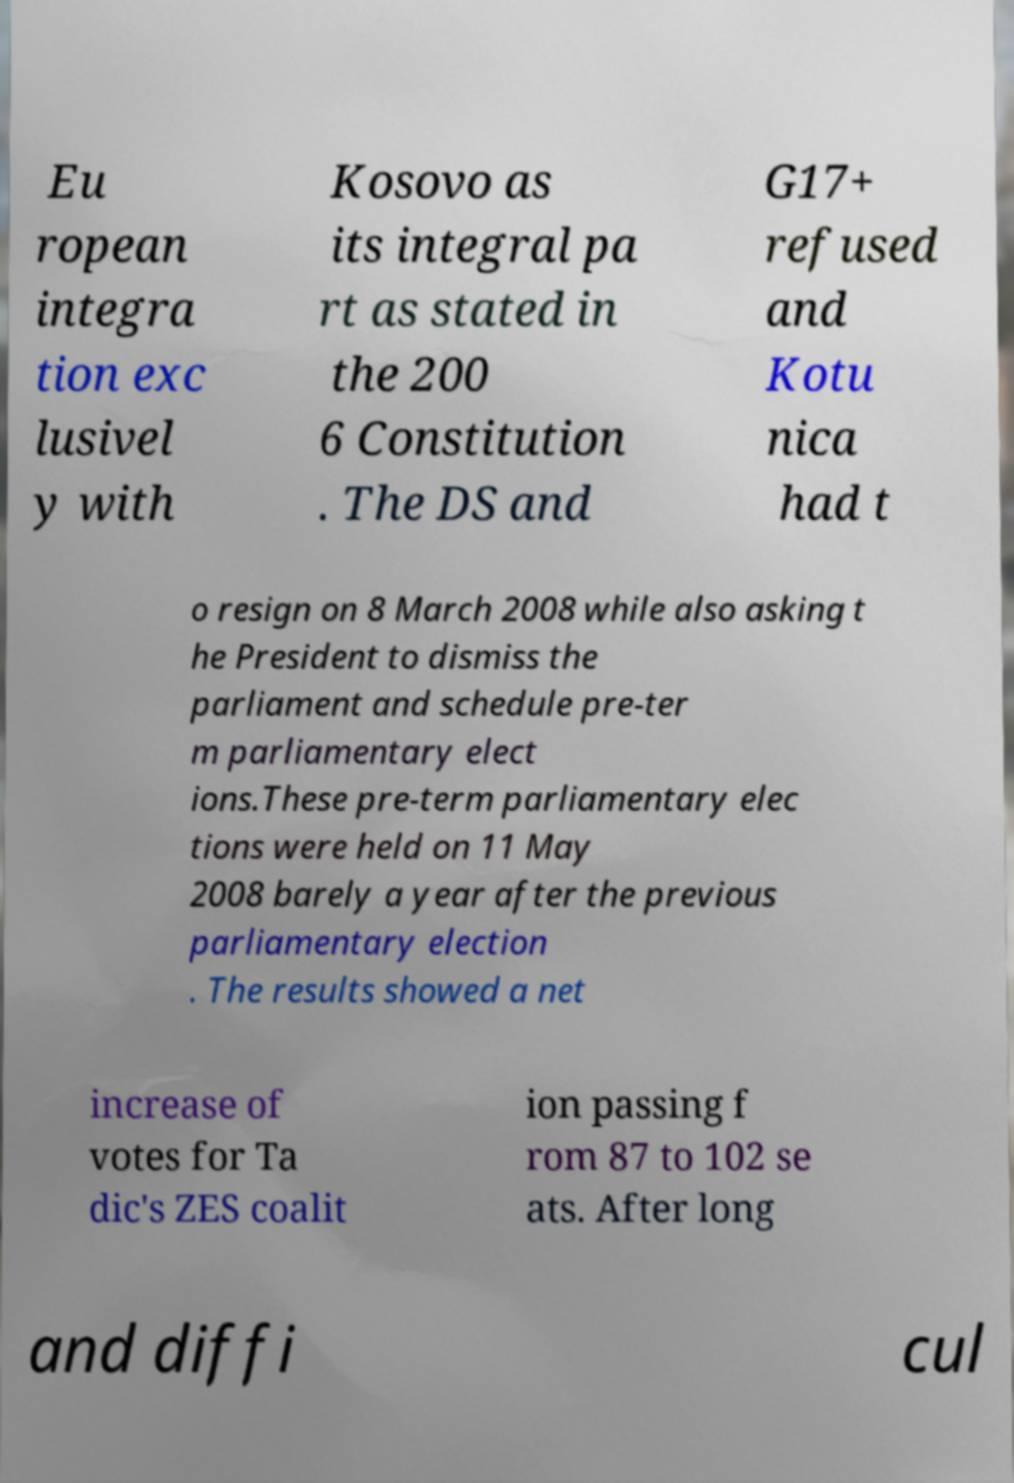What messages or text are displayed in this image? I need them in a readable, typed format. Eu ropean integra tion exc lusivel y with Kosovo as its integral pa rt as stated in the 200 6 Constitution . The DS and G17+ refused and Kotu nica had t o resign on 8 March 2008 while also asking t he President to dismiss the parliament and schedule pre-ter m parliamentary elect ions.These pre-term parliamentary elec tions were held on 11 May 2008 barely a year after the previous parliamentary election . The results showed a net increase of votes for Ta dic's ZES coalit ion passing f rom 87 to 102 se ats. After long and diffi cul 